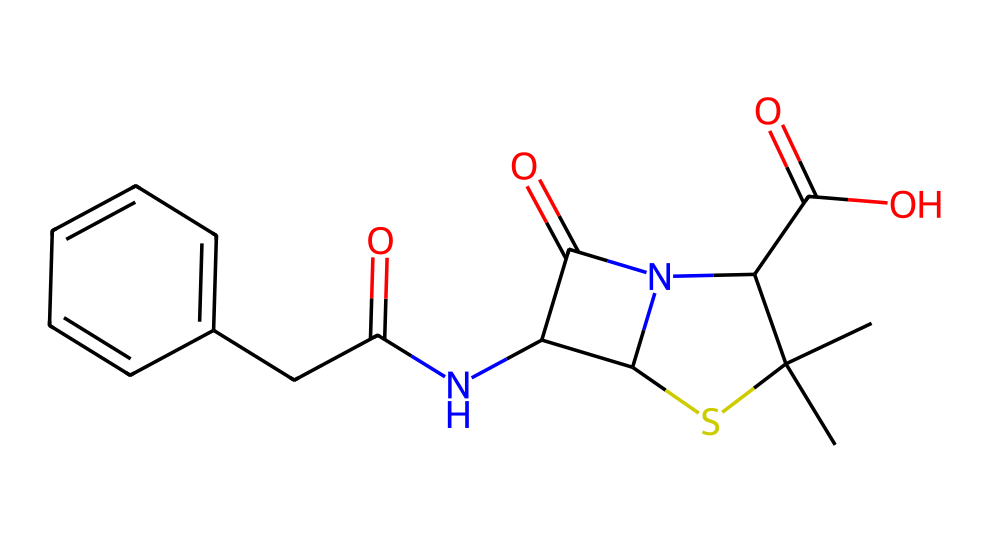What is the total number of nitrogen atoms in this penicillin structure? By examining the SMILES representation, "N" indicates the presence of nitrogen atoms. Counting the occurrences in the chemical, we find two nitrogen atoms in the structure.
Answer: 2 How many sulfur atoms are present in this molecule? The presence of the letter "S" in the SMILES shows the locations of sulfur atoms. There is only one "S" in the entire SMILES representation, indicating one sulfur atom in the structure.
Answer: 1 What type of functional group is present due to the carbonyl groups observed in this molecule? The presence of the "C(=O)" segments indicates carbonyl functional groups. Carbonyl groups include both ketones and aldehydes, but in this structure, they are part of amide or carboxylic acid functional groups as part of the penicillin's structure.
Answer: carbonyl How many rings are present in the penicillin structure? The segments that form part of the rings can be identified in the SMILES notation. Identifying these through visual representations, there is one ring structure shown by "C(S1)" designation in the SMILES that indicates a cyclic compound.
Answer: 1 What is the degree of saturation indicated by the presence of double bonds in this structure? The double bonds present in the structure denote a degree of unsaturation. In this SMILES, there are two double bonds seen in structures of carbonyl groups and an aromatic ring structure, which contribute to the saturation of the whole molecule.
Answer: 2 What does the presence of sulfur in this molecule indicate about its classification? Organosulfur compounds are characterized by the presence of sulfur atoms in their molecular structure. The inclusion of sulfur here classifies this penicillin derivative as an organosulfur compound.
Answer: organosulfur 